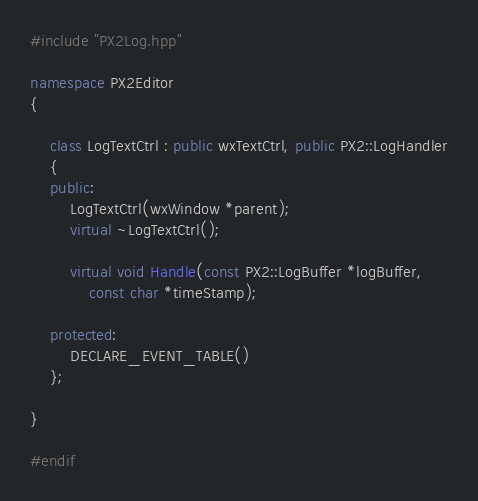<code> <loc_0><loc_0><loc_500><loc_500><_C++_>#include "PX2Log.hpp"

namespace PX2Editor
{

	class LogTextCtrl : public wxTextCtrl, public PX2::LogHandler
	{
	public:
		LogTextCtrl(wxWindow *parent);
		virtual ~LogTextCtrl();

		virtual void Handle(const PX2::LogBuffer *logBuffer,
			const char *timeStamp);

	protected:
		DECLARE_EVENT_TABLE()
	};

}

#endif</code> 